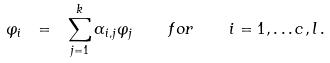<formula> <loc_0><loc_0><loc_500><loc_500>\varphi _ { i } \ = \ \sum _ { j = 1 } ^ { k } \alpha _ { i , j } \varphi _ { j } \quad f o r \quad i = 1 , \dots c , l \, .</formula> 